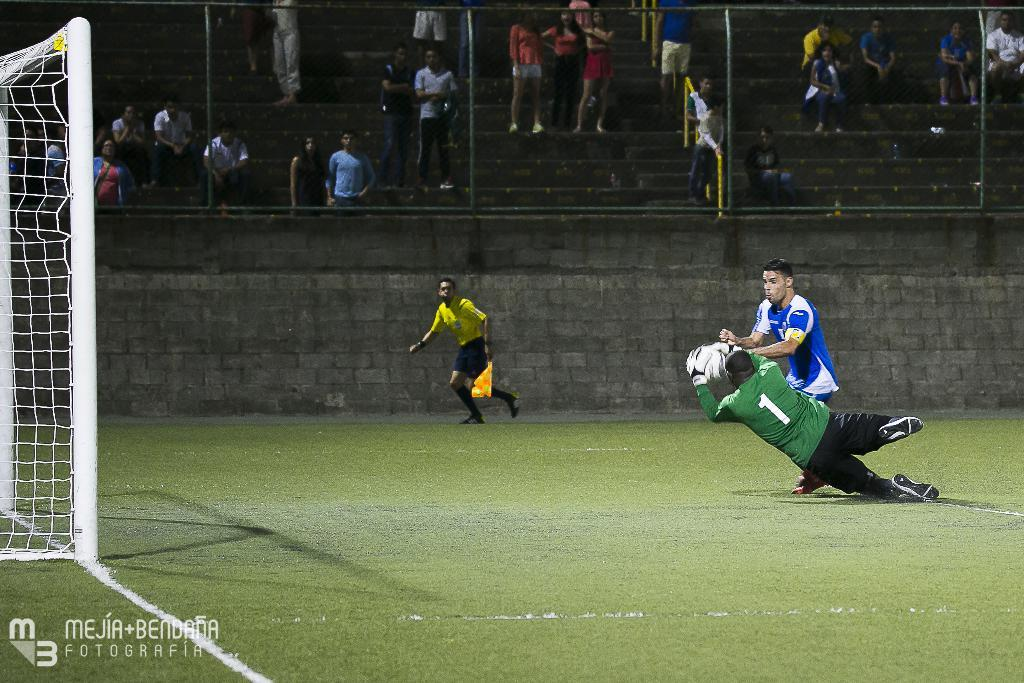<image>
Create a compact narrative representing the image presented. Number 1 wearing green saves a potential goal by the blue team. 